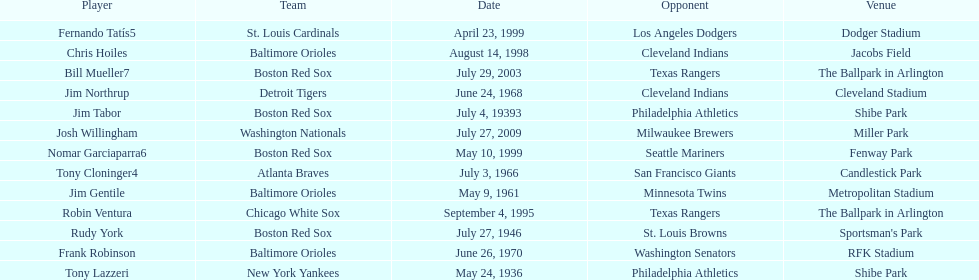Who is the first major league hitter to hit two grand slams in one game? Tony Lazzeri. Parse the table in full. {'header': ['Player', 'Team', 'Date', 'Opponent', 'Venue'], 'rows': [['Fernando Tatís5', 'St. Louis Cardinals', 'April 23, 1999', 'Los Angeles Dodgers', 'Dodger Stadium'], ['Chris Hoiles', 'Baltimore Orioles', 'August 14, 1998', 'Cleveland Indians', 'Jacobs Field'], ['Bill Mueller7', 'Boston Red Sox', 'July 29, 2003', 'Texas Rangers', 'The Ballpark in Arlington'], ['Jim Northrup', 'Detroit Tigers', 'June 24, 1968', 'Cleveland Indians', 'Cleveland Stadium'], ['Jim Tabor', 'Boston Red Sox', 'July 4, 19393', 'Philadelphia Athletics', 'Shibe Park'], ['Josh Willingham', 'Washington Nationals', 'July 27, 2009', 'Milwaukee Brewers', 'Miller Park'], ['Nomar Garciaparra6', 'Boston Red Sox', 'May 10, 1999', 'Seattle Mariners', 'Fenway Park'], ['Tony Cloninger4', 'Atlanta Braves', 'July 3, 1966', 'San Francisco Giants', 'Candlestick Park'], ['Jim Gentile', 'Baltimore Orioles', 'May 9, 1961', 'Minnesota Twins', 'Metropolitan Stadium'], ['Robin Ventura', 'Chicago White Sox', 'September 4, 1995', 'Texas Rangers', 'The Ballpark in Arlington'], ['Rudy York', 'Boston Red Sox', 'July 27, 1946', 'St. Louis Browns', "Sportsman's Park"], ['Frank Robinson', 'Baltimore Orioles', 'June 26, 1970', 'Washington Senators', 'RFK Stadium'], ['Tony Lazzeri', 'New York Yankees', 'May 24, 1936', 'Philadelphia Athletics', 'Shibe Park']]} 